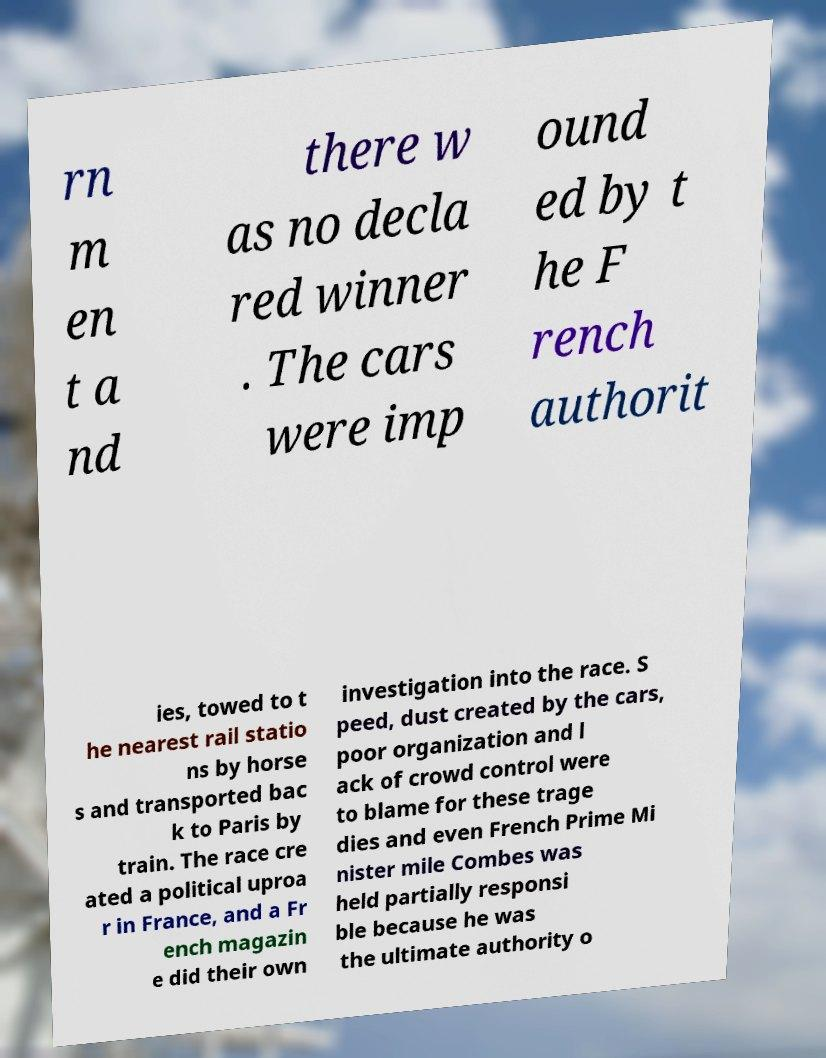For documentation purposes, I need the text within this image transcribed. Could you provide that? rn m en t a nd there w as no decla red winner . The cars were imp ound ed by t he F rench authorit ies, towed to t he nearest rail statio ns by horse s and transported bac k to Paris by train. The race cre ated a political uproa r in France, and a Fr ench magazin e did their own investigation into the race. S peed, dust created by the cars, poor organization and l ack of crowd control were to blame for these trage dies and even French Prime Mi nister mile Combes was held partially responsi ble because he was the ultimate authority o 